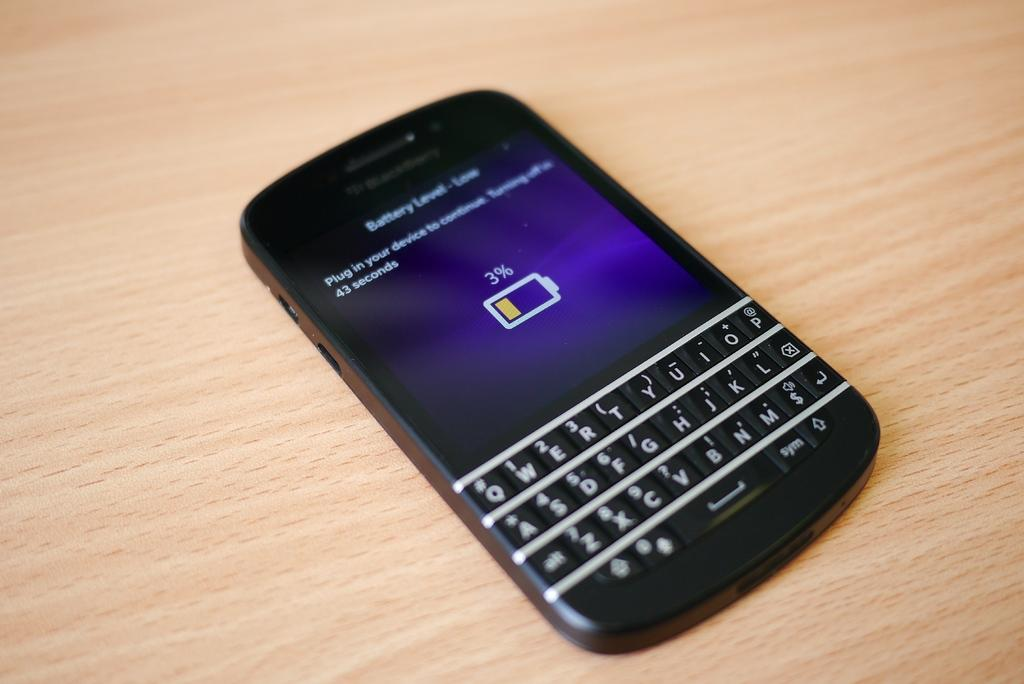Provide a one-sentence caption for the provided image. a black blackberry phone that says 'battery level-low' on the screen. 